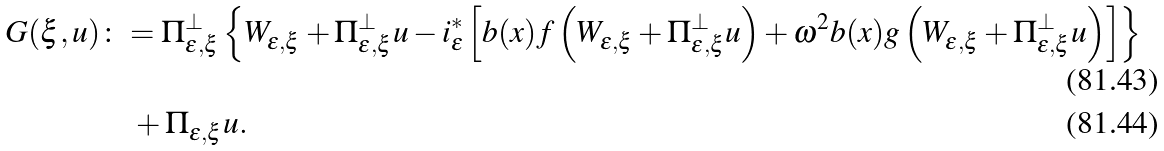Convert formula to latex. <formula><loc_0><loc_0><loc_500><loc_500>G ( \xi , u ) & \colon = \Pi _ { \varepsilon , \xi } ^ { \perp } \left \{ W _ { \varepsilon , \xi } + \Pi _ { \varepsilon , \xi } ^ { \perp } u - i _ { \varepsilon } ^ { \ast } \left [ b ( x ) f \left ( W _ { \varepsilon , \xi } + \Pi _ { \varepsilon , \xi } ^ { \perp } u \right ) + \omega ^ { 2 } b ( x ) g \left ( W _ { \varepsilon , \xi } + \Pi _ { \varepsilon , \xi } ^ { \perp } u \right ) \right ] \right \} \\ & \quad + \Pi _ { \varepsilon , \xi } u .</formula> 